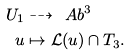Convert formula to latex. <formula><loc_0><loc_0><loc_500><loc_500>U _ { 1 } & \dashrightarrow \ A b ^ { 3 } \\ u & \mapsto \mathcal { L } ( u ) \cap T _ { 3 } .</formula> 